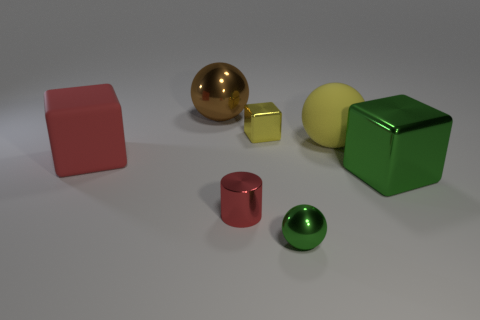There is a thing that is the same color as the big rubber block; what is it made of?
Offer a very short reply. Metal. Do the red cylinder and the large red block have the same material?
Ensure brevity in your answer.  No. Are there any cylinders on the left side of the tiny green metal object?
Offer a terse response. Yes. There is a large block that is to the right of the large sphere behind the yellow sphere; what is its material?
Ensure brevity in your answer.  Metal. There is a green object that is the same shape as the brown object; what is its size?
Ensure brevity in your answer.  Small. Do the tiny cylinder and the matte cube have the same color?
Your response must be concise. Yes. There is a sphere that is behind the tiny cylinder and in front of the yellow block; what is its color?
Ensure brevity in your answer.  Yellow. There is a red object that is in front of the red matte object; is it the same size as the tiny green object?
Keep it short and to the point. Yes. Are there any other things that are the same shape as the red metal thing?
Provide a succinct answer. No. Does the large yellow thing have the same material as the red object behind the small red metal cylinder?
Keep it short and to the point. Yes. 